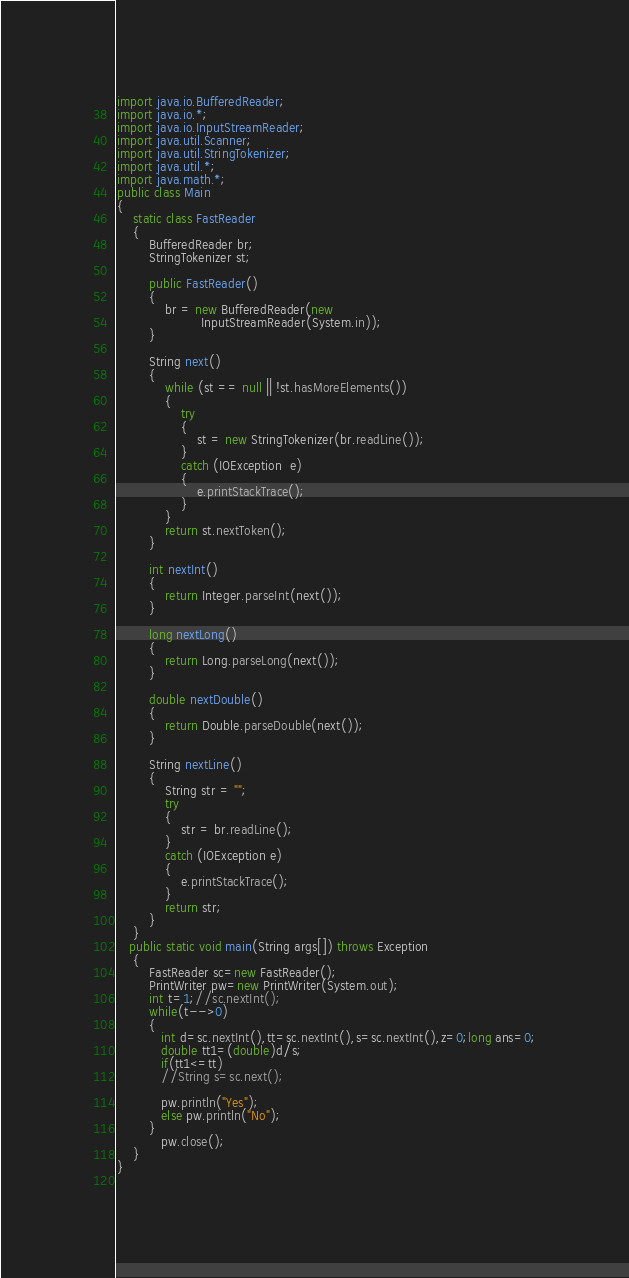Convert code to text. <code><loc_0><loc_0><loc_500><loc_500><_Java_>import java.io.BufferedReader; 
import java.io.*;
import java.io.InputStreamReader; 
import java.util.Scanner; 
import java.util.StringTokenizer; 
import java.util.*;
import java.math.*;
public class Main 
{ 
    static class FastReader 
    { 
        BufferedReader br; 
        StringTokenizer st; 
  
        public FastReader()
        { 
            br = new BufferedReader(new
                     InputStreamReader(System.in)); 
        } 
  
        String next()
        { 
            while (st == null || !st.hasMoreElements()) 
            { 
                try
                { 
                    st = new StringTokenizer(br.readLine()); 
                } 
                catch (IOException  e) 
                { 
                    e.printStackTrace(); 
                } 
            } 
            return st.nextToken(); 
        } 
  
        int nextInt() 
        { 
            return Integer.parseInt(next()); 
        } 
  
        long nextLong() 
        { 
            return Long.parseLong(next()); 
        } 
  
        double nextDouble() 
        { 
            return Double.parseDouble(next()); 
        } 
  
        String nextLine() 
        { 
            String str = ""; 
            try
            { 
                str = br.readLine();
            } 
            catch (IOException e) 
            { 
                e.printStackTrace(); 
            } 
            return str; 
        } 
    } 
   public static void main(String args[]) throws Exception
    {
        FastReader sc=new FastReader();
        PrintWriter pw=new PrintWriter(System.out);
        int t=1;//sc.nextInt();
        while(t-->0)
        {
           int d=sc.nextInt(),tt=sc.nextInt(),s=sc.nextInt(),z=0;long ans=0;
           double tt1=(double)d/s;
           if(tt1<=tt)
           //String s=sc.next();
           
           pw.println("Yes");
           else pw.println("No");
        }
           pw.close();
    }
}
  </code> 